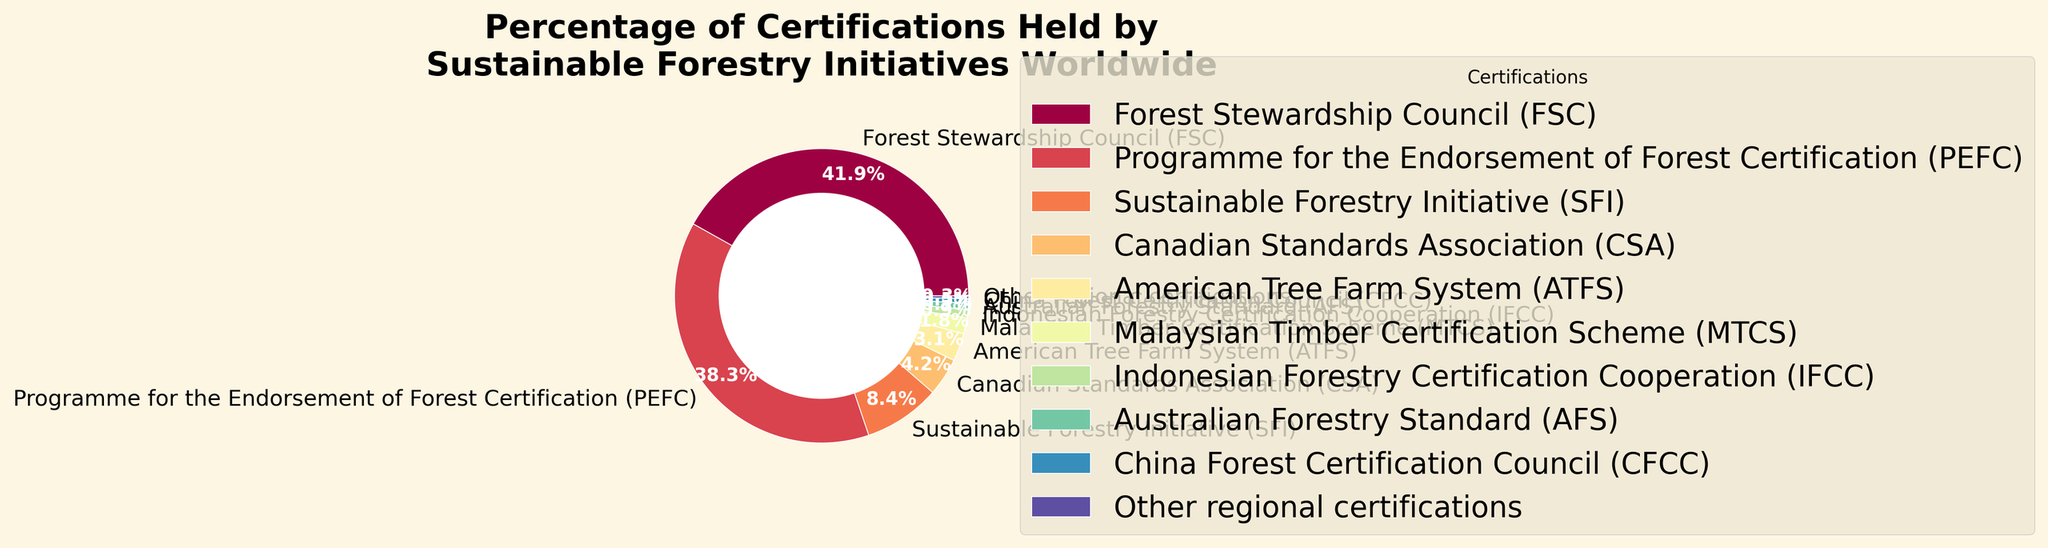What is the percentage of certifications held by the Forest Stewardship Council (FSC)? Look at the segment labeled "Forest Stewardship Council (FSC)" and find its corresponding percentage value.
Answer: 42.3% What is the combined percentage of certifications held by FSC and PEFC? Add the percentages of the "Forest Stewardship Council (FSC)" and the "Programme for the Endorsement of Forest Certification (PEFC)" segments. Calculation: 42.3% + 38.7% = 81%
Answer: 81% Which certification has the smallest percentage, and what is that percentage? Look for the smallest value in the pie chart segments, which is labeled as "Other regional certifications" with a corresponding percentage of 0.3%.
Answer: Other regional certifications, 0.3% Are there more certifications from the Canadian Standards Association (CSA) or the American Tree Farm System (ATFS)? Compare the segments labeled "Canadian Standards Association (CSA)" and "American Tree Farm System (ATFS)". CSA has 4.2%, and ATFS has 3.1%, so CSA has more.
Answer: CSA What is the total percentage of certifications from all certifications that are less than 5% each? Add the percentages of SFI (8.5%), CSA (4.2%), ATFS (3.1%), MTCS (1.8%), IFCC (0.9%), AFS (0.7%), CFCC (0.5%), and Other regional certifications (0.3%) that are less than 5%. Calculation: 4.2% + 3.1% + 1.8% + 0.9% + 0.7% + 0.5% + 0.3% = 11.5%
Answer: 11.5% Which organization holds a greater percentage of certifications, the Sustainable Forestry Initiative (SFI) or the Malaysian Timber Certification Scheme (MTCS)? Compare the segments for "Sustainable Forestry Initiative (SFI)" (8.5%) and "Malaysian Timber Certification Scheme (MTCS)" (1.8%). SFI has a greater percentage.
Answer: SFI What is the difference in percentage between PEFC and CSA certifications? Subtract the CSA percentage from the PEFC percentage. Calculation: 38.7% - 4.2% = 34.5%
Answer: 34.5% Which certifications collectively represent more than 50% of the total certifications? Identify segments individually greater or in total sum greater than 50%. FSC with 42.3% and PEFC with 38.7% together exceed 50%.
Answer: FSC and PEFC What percentage do the PEFC, MTCS, and IFCC hold together? Add the percentages of PEFC (38.7%), MTCS (1.8%), and IFCC (0.9%). Calculation: 38.7% + 1.8% + 0.9% = 41.4%
Answer: 41.4% 